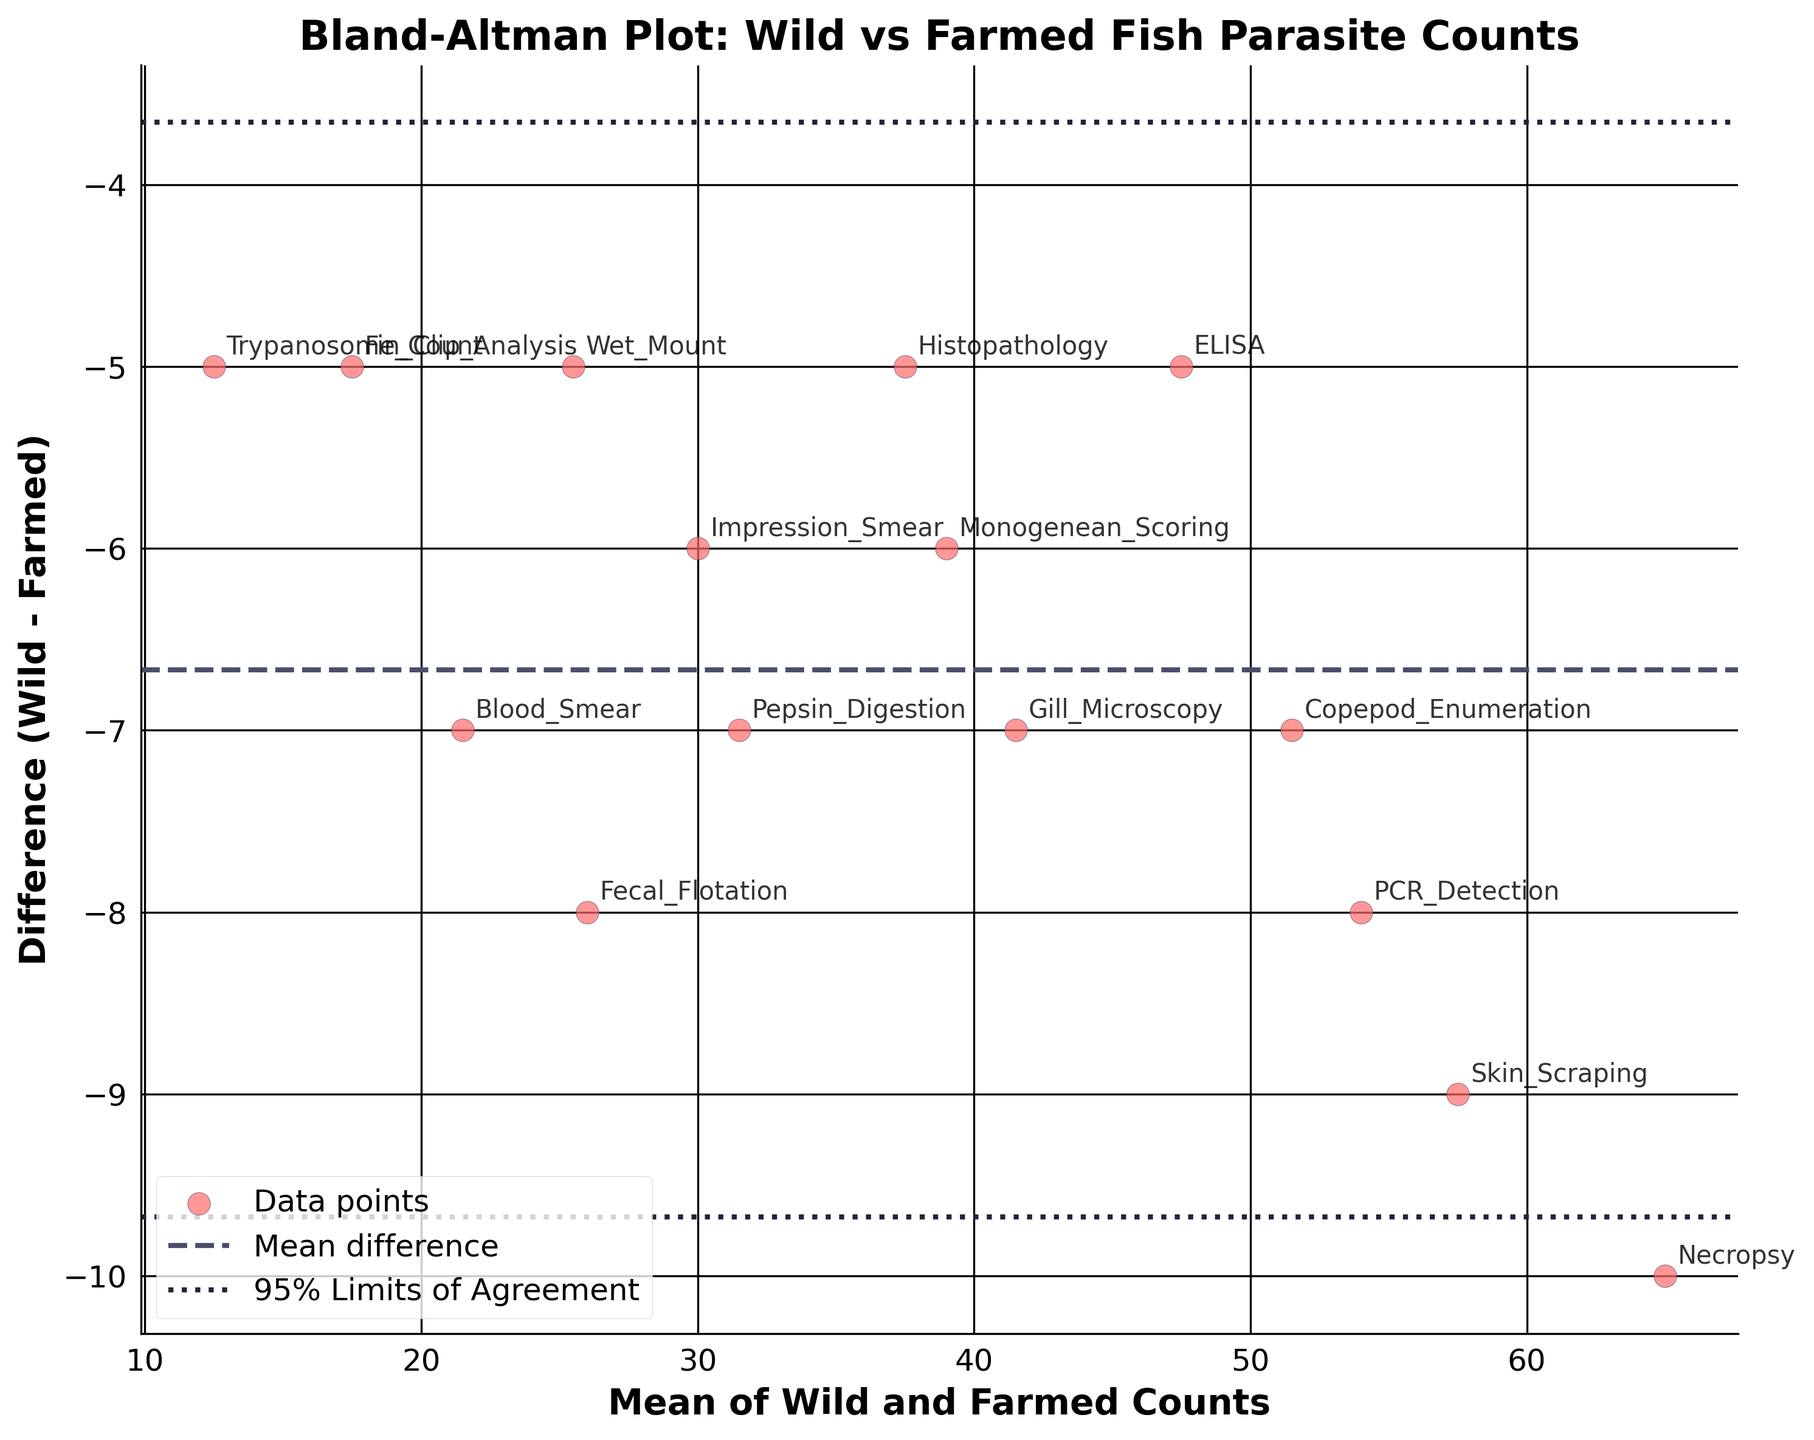What's the title of the figure? The title of a figure provides a summary of what the figure depicts. The title is usually located at the top of the figure. Here, the title reads "Bland-Altman Plot: Wild vs Farmed Fish Parasite Counts".
Answer: Bland-Altman Plot: Wild vs Farmed Fish Parasite Counts How many data points are plotted on the figure? Each method is represented as a data point on the scatter plot. Count the number of distinct points or method labels shown on the figure. There are 15 methods, hence 15 data points.
Answer: 15 What is shown on the x-axis? The x-axis label describes what the axis represents. In this figure, the x-axis represents the "Mean of Wild and Farmed Counts".
Answer: Mean of Wild and Farmed Counts What does the dashed horizontal line in the middle represent? In a Bland-Altman plot, the dashed horizontal line typically indicates the mean difference between the two sets of measurements (i.e., Wild and Farmed Counts). This helps assess the average bias between the methods.
Answer: Mean difference What do the dotted horizontal lines represent? In a Bland-Altman plot, the dotted horizontal lines are known as the limits of agreement. They are calculated as the mean difference ± 1.96 times the standard deviation of the differences. These lines show the range within which most differences between the two sets of measurements lie.
Answer: 95% Limits of Agreement Which method has the largest mean parasite count? To find the method with the largest mean parasite count, locate the data point that is furthest to the right on the x-axis. This indicates the highest average value between Wild_Count and Farmed_Count. The method labeled "Necropsy" is farthest to the right.
Answer: Necropsy Which method shows the smallest difference between Wild_Count and Farmed_Count? Look for the data point closest to the x-axis or 0 on the y-axis, indicating the smallest difference between Wild_Count and Farmed_Count. The methods labeled "Histopathology", "Fin_Clip_Analysis", "Wet_Mount", and "Trypanosome_Count" all have differences of -5.
Answer: Histopathology, Fin_Clip_Analysis, Wet_Mount, Trypanosome_Count What is the mean of the differences for all methods? To compute the mean difference, add up the differences and divide by the number of methods. The sum of the differences is (-7 - 9 - 8 - 8 - 5 - 7 - 7 - 5 - 5 - 10 - 5 - 6 - 5 - 7 - 6) = -100, and there are 15 differences, so -100 / 15 = -6.67.
Answer: -6.67 Which method has a mean parasite count of 50? Find the point on the plot where the x-axis is labeled "50". The method labeled near this point is the required method. "ELISA" has a mean parasite count of 50.
Answer: ELISA Do any methods show a difference outside the 95% Limits of Agreement? Examine the figure to determine if any points lie outside the dotted horizontal lines, which represent the 95% limits of agreement. All points fall within these lines, thus no method shows a difference outside the 95% limits.
Answer: No 